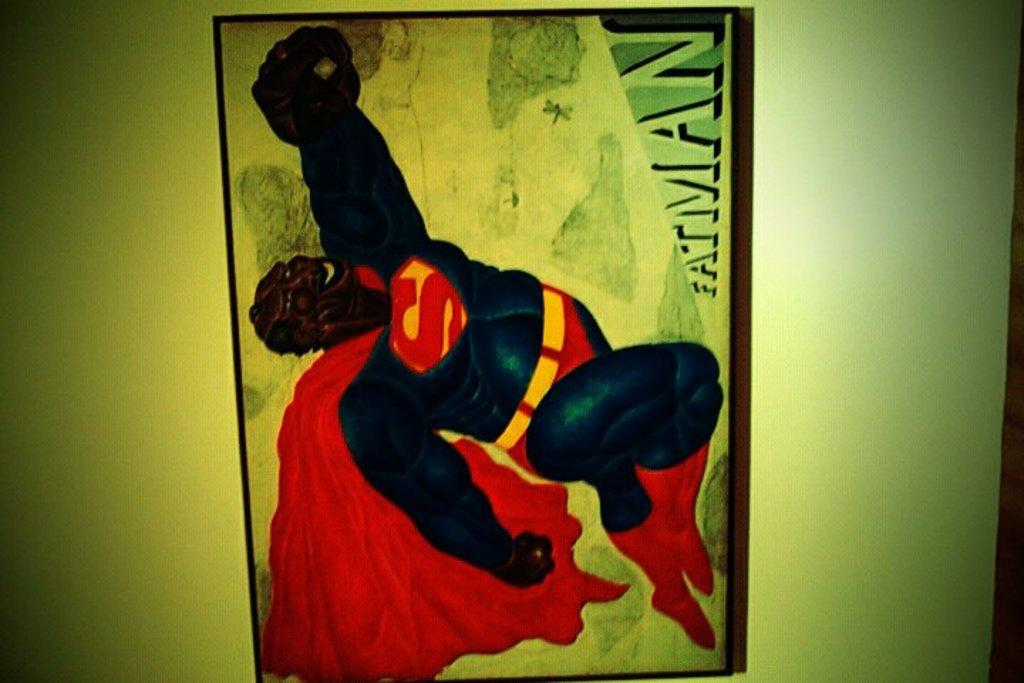<image>
Summarize the visual content of the image. A cartoonish drawing of a black man wearing a Superman costume with the name Fatman written at the bottom. 